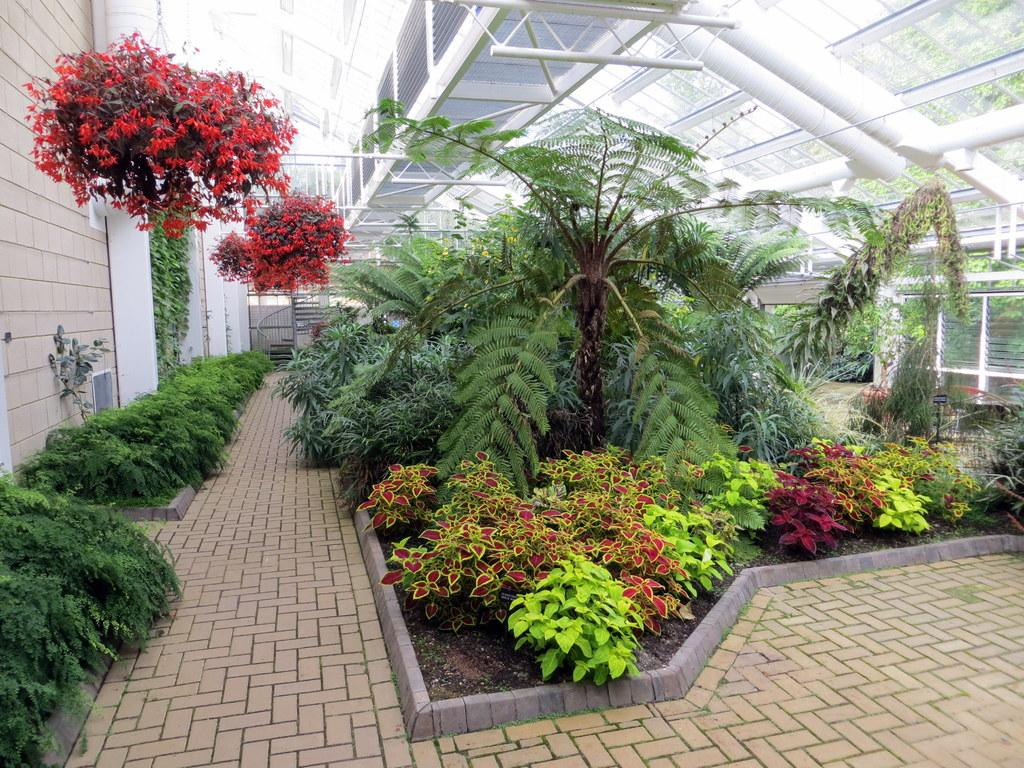What type of plants can be seen in the image? There are colorful plants in the image. What material is used for the walls on the right side of the image? There are glass walls on the right side of the image. What type of wall is on the left side of the image? There is a brick wall on the left side of the image. What type of brass can be seen in the image? There is no brass present in the image. How many buckets are visible in the image? There are no buckets present in the image. 